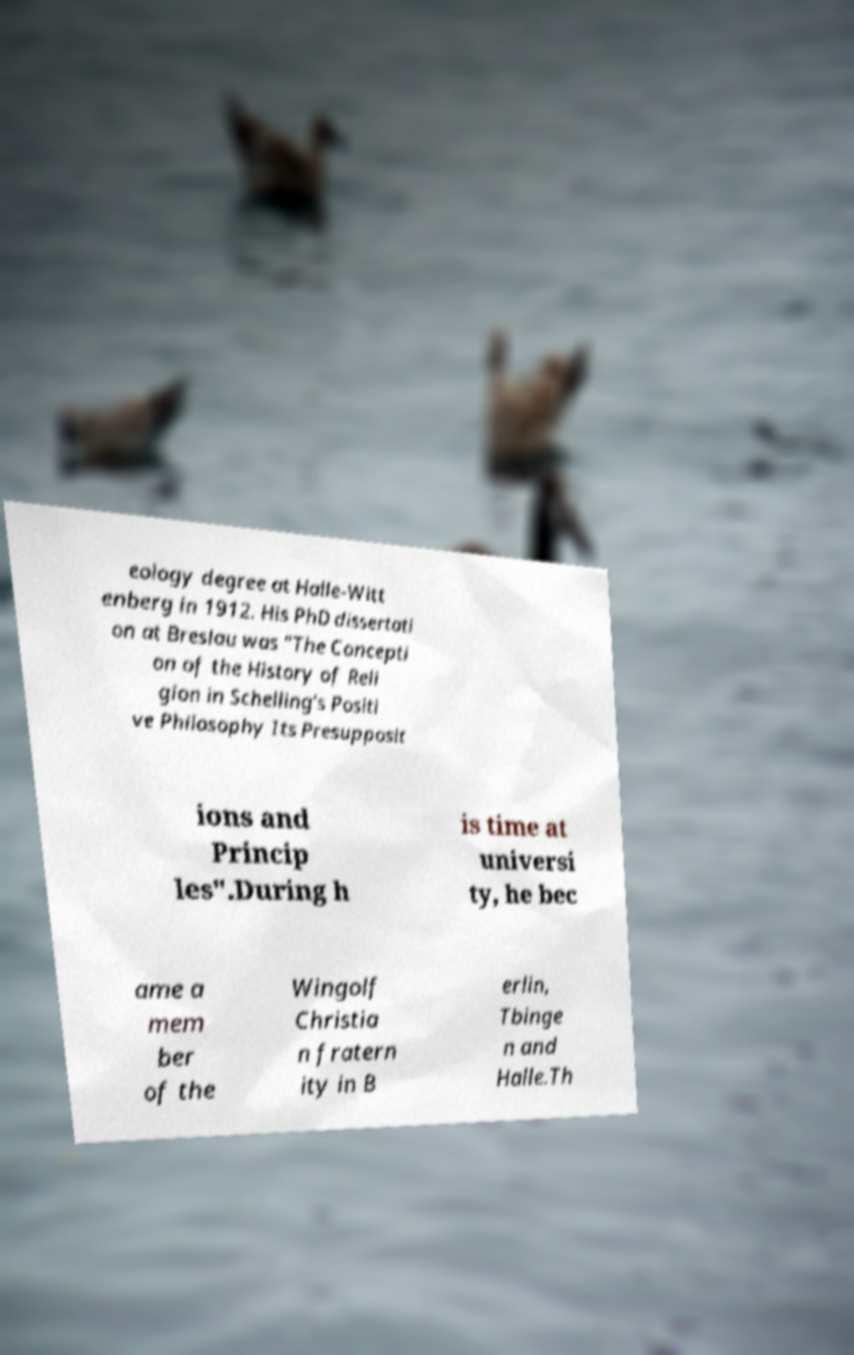What messages or text are displayed in this image? I need them in a readable, typed format. eology degree at Halle-Witt enberg in 1912. His PhD dissertati on at Breslau was "The Concepti on of the History of Reli gion in Schelling's Positi ve Philosophy Its Presupposit ions and Princip les".During h is time at universi ty, he bec ame a mem ber of the Wingolf Christia n fratern ity in B erlin, Tbinge n and Halle.Th 